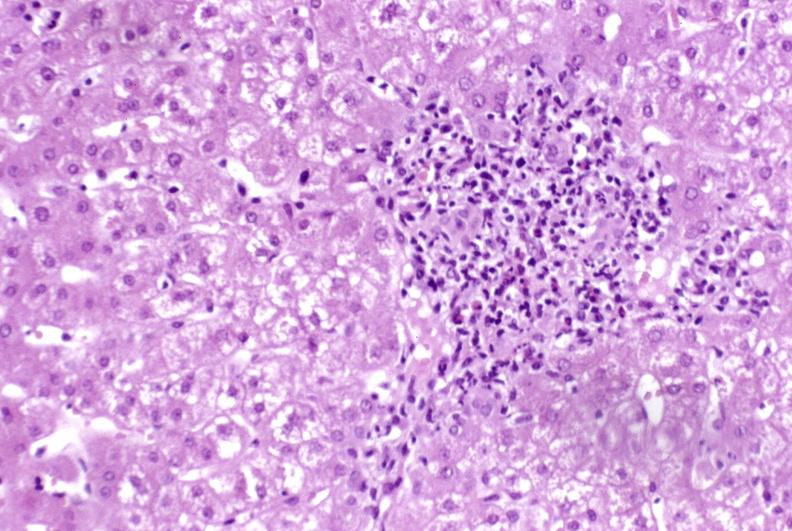s liver present?
Answer the question using a single word or phrase. Yes 